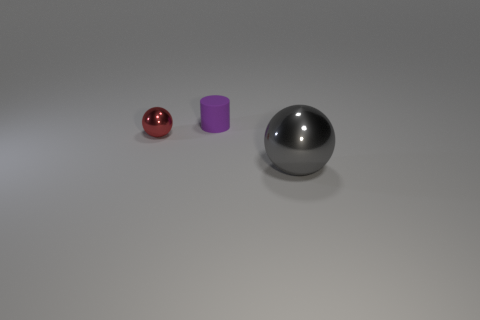Subtract all green cylinders. Subtract all green balls. How many cylinders are left? 1 Add 3 tiny metallic cylinders. How many objects exist? 6 Subtract all spheres. How many objects are left? 1 Subtract 0 brown cylinders. How many objects are left? 3 Subtract all gray rubber cylinders. Subtract all tiny rubber cylinders. How many objects are left? 2 Add 3 metal balls. How many metal balls are left? 5 Add 2 large green rubber blocks. How many large green rubber blocks exist? 2 